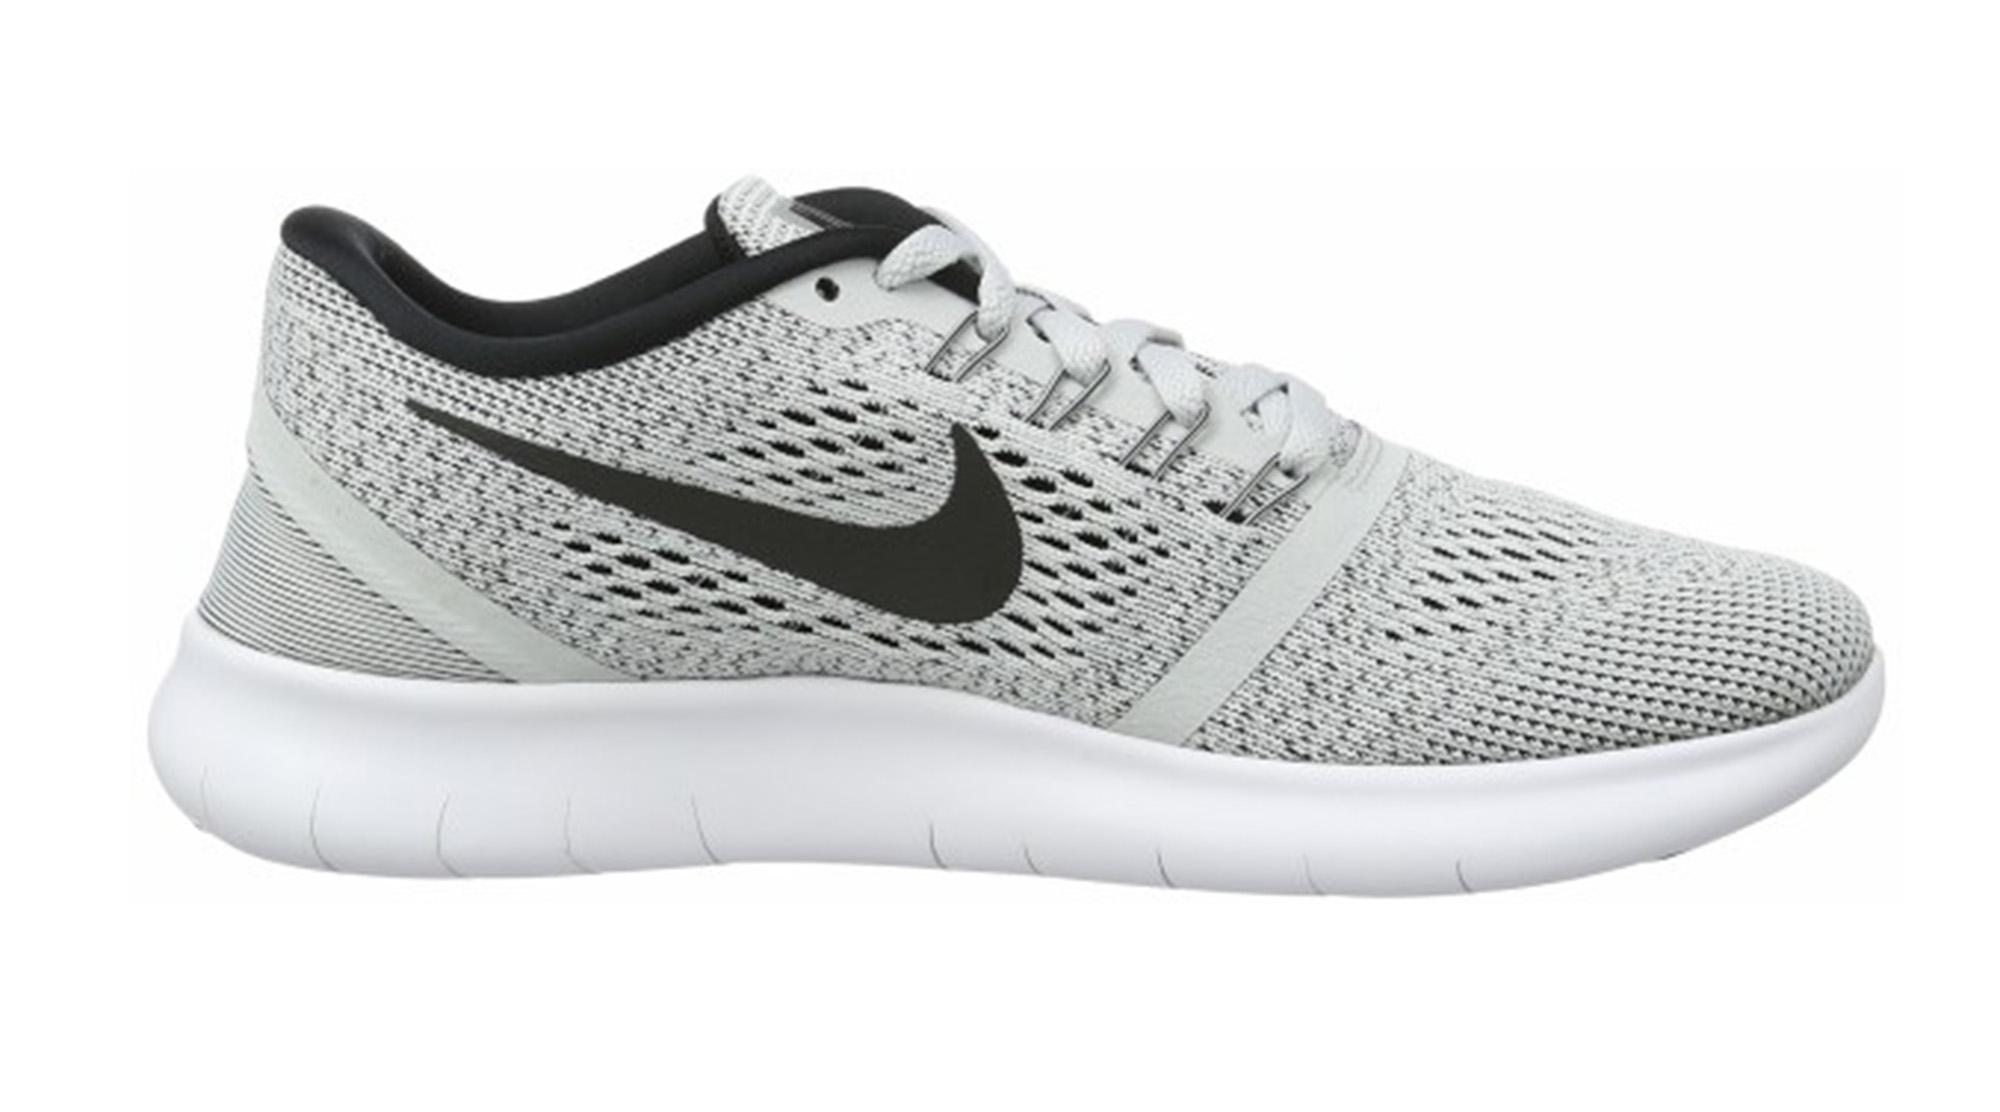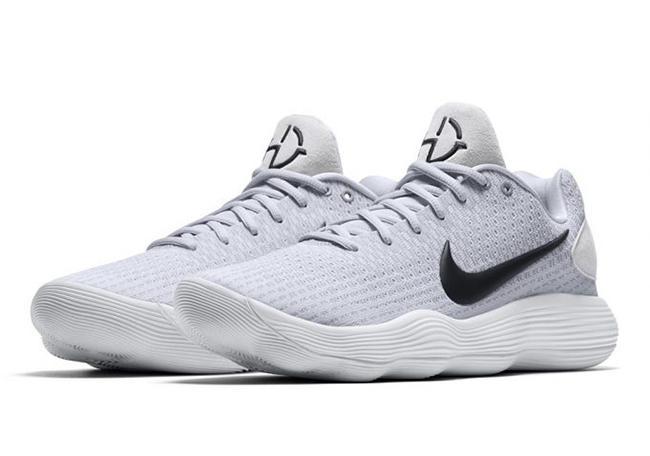The first image is the image on the left, the second image is the image on the right. Analyze the images presented: Is the assertion "There are exactly two shoes shown in one of the images." valid? Answer yes or no. Yes. 